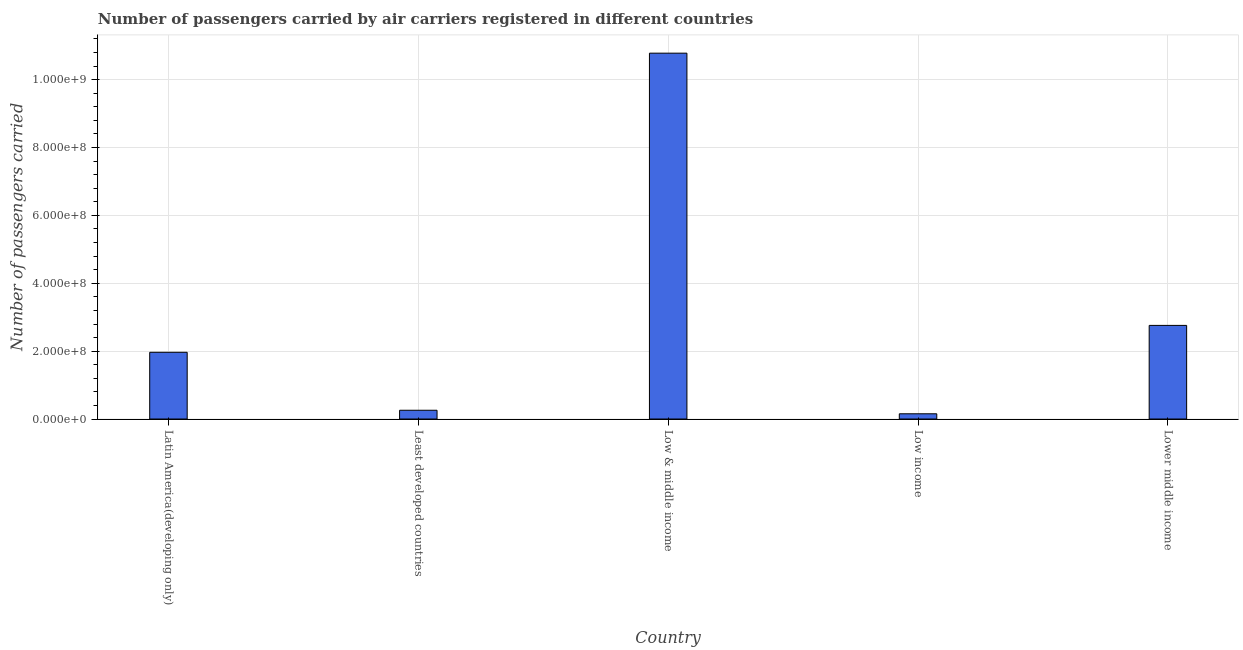Does the graph contain any zero values?
Keep it short and to the point. No. What is the title of the graph?
Give a very brief answer. Number of passengers carried by air carriers registered in different countries. What is the label or title of the Y-axis?
Offer a terse response. Number of passengers carried. What is the number of passengers carried in Low income?
Offer a very short reply. 1.54e+07. Across all countries, what is the maximum number of passengers carried?
Give a very brief answer. 1.08e+09. Across all countries, what is the minimum number of passengers carried?
Provide a short and direct response. 1.54e+07. What is the sum of the number of passengers carried?
Keep it short and to the point. 1.59e+09. What is the difference between the number of passengers carried in Least developed countries and Low income?
Provide a succinct answer. 1.04e+07. What is the average number of passengers carried per country?
Provide a short and direct response. 3.18e+08. What is the median number of passengers carried?
Make the answer very short. 1.97e+08. What is the ratio of the number of passengers carried in Low income to that in Lower middle income?
Offer a terse response. 0.06. Is the number of passengers carried in Least developed countries less than that in Low income?
Make the answer very short. No. Is the difference between the number of passengers carried in Latin America(developing only) and Low & middle income greater than the difference between any two countries?
Offer a terse response. No. What is the difference between the highest and the second highest number of passengers carried?
Make the answer very short. 8.02e+08. Is the sum of the number of passengers carried in Latin America(developing only) and Least developed countries greater than the maximum number of passengers carried across all countries?
Your answer should be compact. No. What is the difference between the highest and the lowest number of passengers carried?
Keep it short and to the point. 1.06e+09. In how many countries, is the number of passengers carried greater than the average number of passengers carried taken over all countries?
Your response must be concise. 1. How many bars are there?
Provide a succinct answer. 5. What is the difference between two consecutive major ticks on the Y-axis?
Keep it short and to the point. 2.00e+08. Are the values on the major ticks of Y-axis written in scientific E-notation?
Offer a very short reply. Yes. What is the Number of passengers carried in Latin America(developing only)?
Provide a succinct answer. 1.97e+08. What is the Number of passengers carried of Least developed countries?
Your answer should be compact. 2.58e+07. What is the Number of passengers carried in Low & middle income?
Provide a succinct answer. 1.08e+09. What is the Number of passengers carried of Low income?
Your answer should be compact. 1.54e+07. What is the Number of passengers carried in Lower middle income?
Keep it short and to the point. 2.76e+08. What is the difference between the Number of passengers carried in Latin America(developing only) and Least developed countries?
Offer a terse response. 1.71e+08. What is the difference between the Number of passengers carried in Latin America(developing only) and Low & middle income?
Offer a terse response. -8.81e+08. What is the difference between the Number of passengers carried in Latin America(developing only) and Low income?
Offer a very short reply. 1.81e+08. What is the difference between the Number of passengers carried in Latin America(developing only) and Lower middle income?
Your response must be concise. -7.92e+07. What is the difference between the Number of passengers carried in Least developed countries and Low & middle income?
Ensure brevity in your answer.  -1.05e+09. What is the difference between the Number of passengers carried in Least developed countries and Low income?
Keep it short and to the point. 1.04e+07. What is the difference between the Number of passengers carried in Least developed countries and Lower middle income?
Offer a very short reply. -2.50e+08. What is the difference between the Number of passengers carried in Low & middle income and Low income?
Give a very brief answer. 1.06e+09. What is the difference between the Number of passengers carried in Low & middle income and Lower middle income?
Provide a short and direct response. 8.02e+08. What is the difference between the Number of passengers carried in Low income and Lower middle income?
Provide a short and direct response. -2.60e+08. What is the ratio of the Number of passengers carried in Latin America(developing only) to that in Least developed countries?
Offer a very short reply. 7.63. What is the ratio of the Number of passengers carried in Latin America(developing only) to that in Low & middle income?
Provide a succinct answer. 0.18. What is the ratio of the Number of passengers carried in Latin America(developing only) to that in Low income?
Give a very brief answer. 12.75. What is the ratio of the Number of passengers carried in Latin America(developing only) to that in Lower middle income?
Ensure brevity in your answer.  0.71. What is the ratio of the Number of passengers carried in Least developed countries to that in Low & middle income?
Keep it short and to the point. 0.02. What is the ratio of the Number of passengers carried in Least developed countries to that in Low income?
Make the answer very short. 1.67. What is the ratio of the Number of passengers carried in Least developed countries to that in Lower middle income?
Your answer should be very brief. 0.09. What is the ratio of the Number of passengers carried in Low & middle income to that in Low income?
Your answer should be very brief. 69.92. What is the ratio of the Number of passengers carried in Low & middle income to that in Lower middle income?
Your response must be concise. 3.91. What is the ratio of the Number of passengers carried in Low income to that in Lower middle income?
Keep it short and to the point. 0.06. 